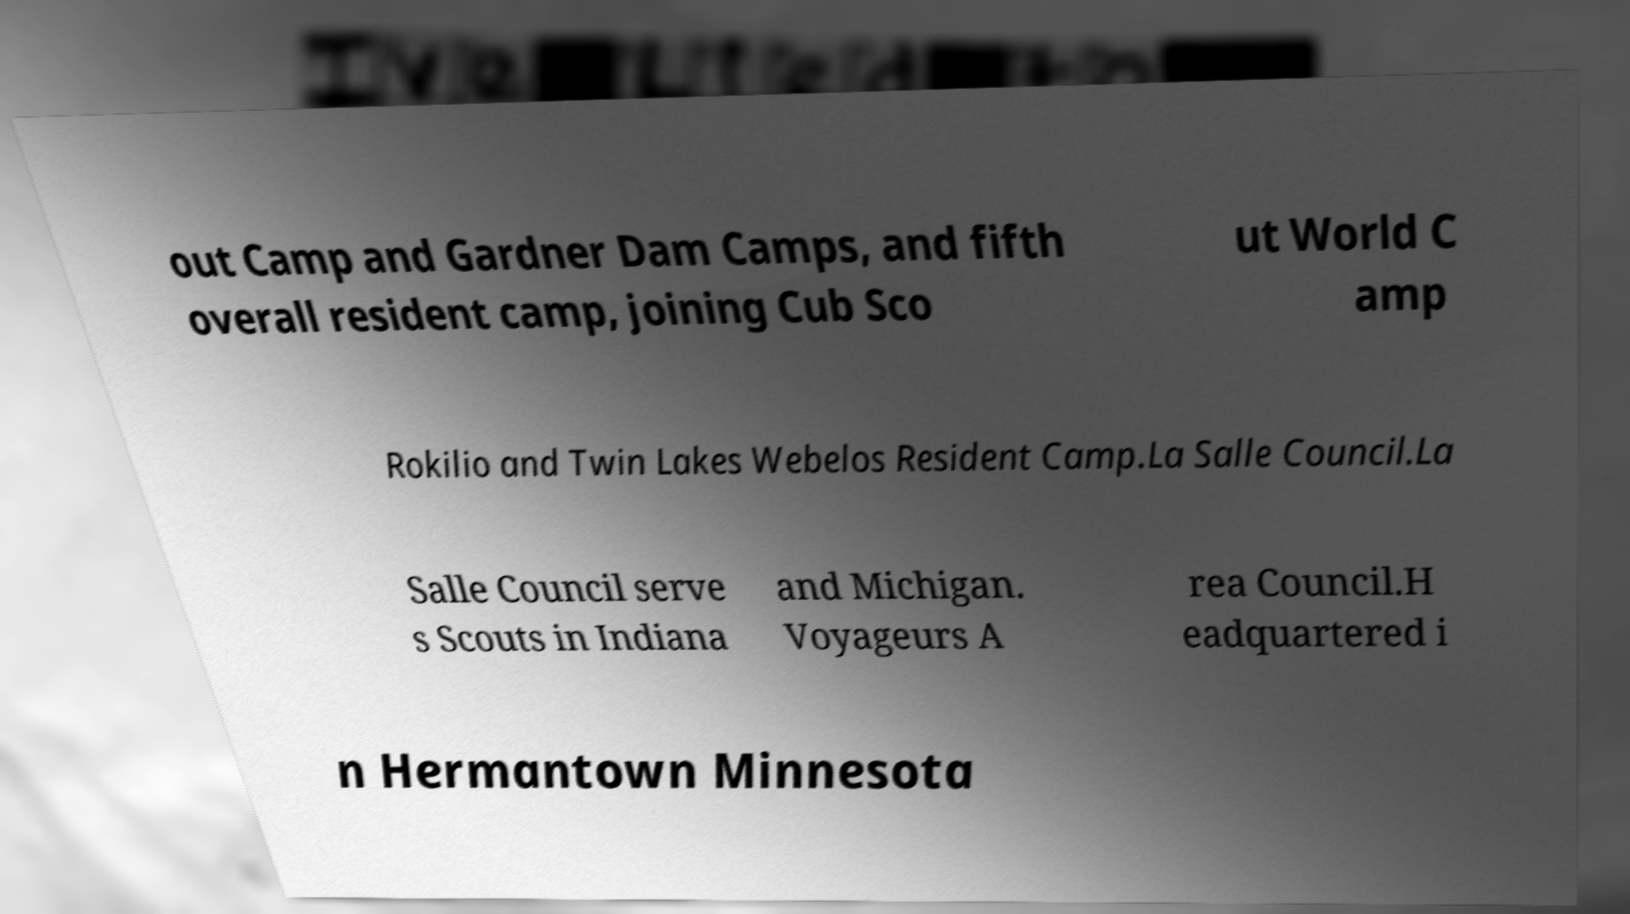There's text embedded in this image that I need extracted. Can you transcribe it verbatim? out Camp and Gardner Dam Camps, and fifth overall resident camp, joining Cub Sco ut World C amp Rokilio and Twin Lakes Webelos Resident Camp.La Salle Council.La Salle Council serve s Scouts in Indiana and Michigan. Voyageurs A rea Council.H eadquartered i n Hermantown Minnesota 